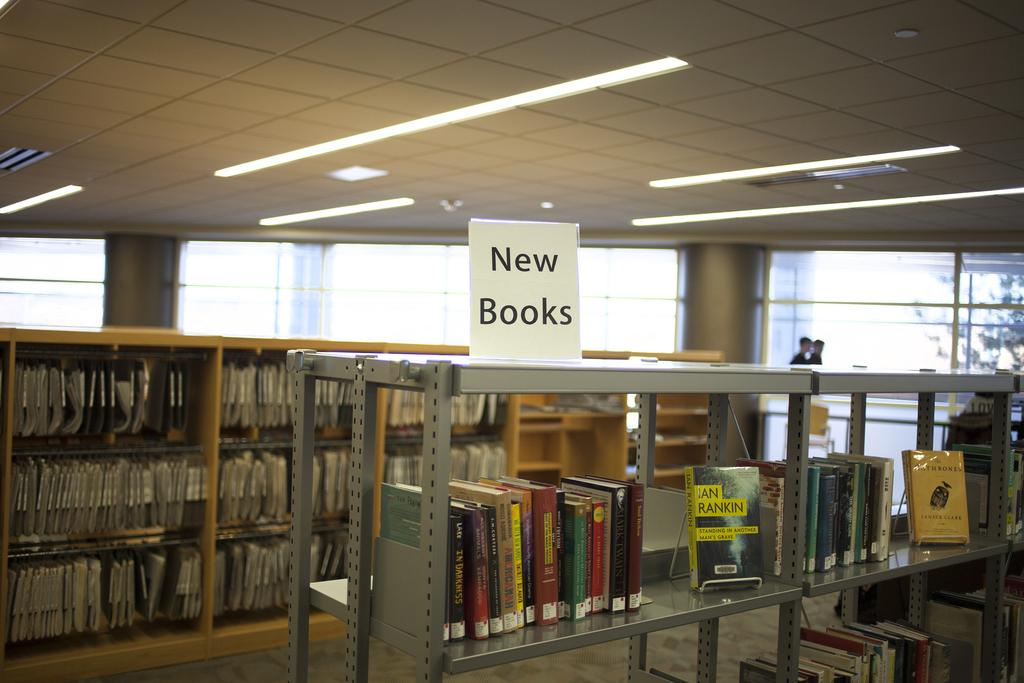What can be seen in the image that provides illumination? There are lights in the image. What type of objects are present in the image that are related to learning or reading? There are books in the image. How are the books organized in the image? The books are in racks. What can be seen in the background of the image that represents the natural environment? There are trees in the background of the image. Where is the jar located in the image? There is no jar present in the image. What type of discussion is taking place in the image? There is no discussion taking place in the image; it only shows lights, books, racks, and trees. --- Facts: 1. There is a car in the image. 2. The car is red. 3. The car has four wheels. 4. There is a road in the image. 5. The road is paved. Absurd Topics: parrot, ocean, dance Conversation: What type of vehicle is in the image? There is a car in the image. What color is the car? The car is red. How many wheels does the car have? The car has four wheels. What type of surface is the car driving on in the image? There is a road in the image, and it is paved. Reasoning: Let's think step by step in order to produce the conversation. We start by identifying the main subject in the image, which is the car. Then, we expand the conversation to include other details about the car, such as its color and the number of wheels. Finally, we describe the setting in which the car is located, mentioning the road and its paved surface. Each question is designed to elicit a specific detail about the image that is known from the provided facts. Absurd Question/Answer: Can you see a parrot flying over the car in the image? There is no parrot present in the image. Is there an ocean visible in the background of the image? There is no ocean visible in the image; it only shows a car, a road, and a paved surface. 